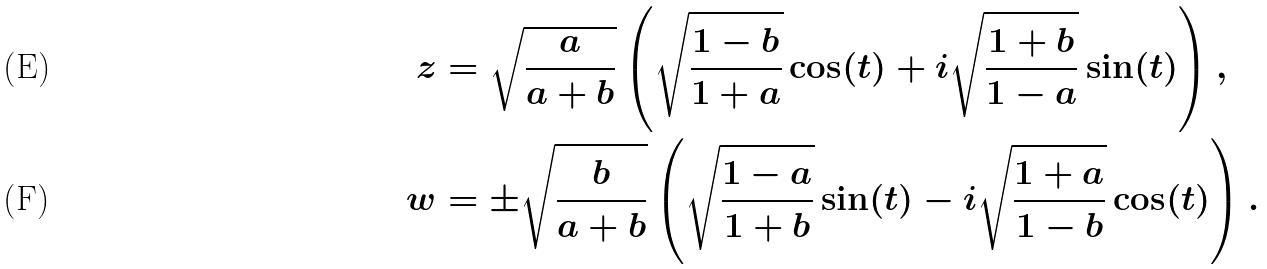Convert formula to latex. <formula><loc_0><loc_0><loc_500><loc_500>z & = \sqrt { \frac { a } { a + b } } \left ( \sqrt { \frac { 1 - b } { 1 + a } } \cos ( t ) + i \sqrt { \frac { 1 + b } { 1 - a } } \sin ( t ) \right ) , \\ w & = \pm \sqrt { \frac { b } { a + b } } \left ( \sqrt { \frac { 1 - a } { 1 + b } } \sin ( t ) - i \sqrt { \frac { 1 + a } { 1 - b } } \cos ( t ) \right ) .</formula> 